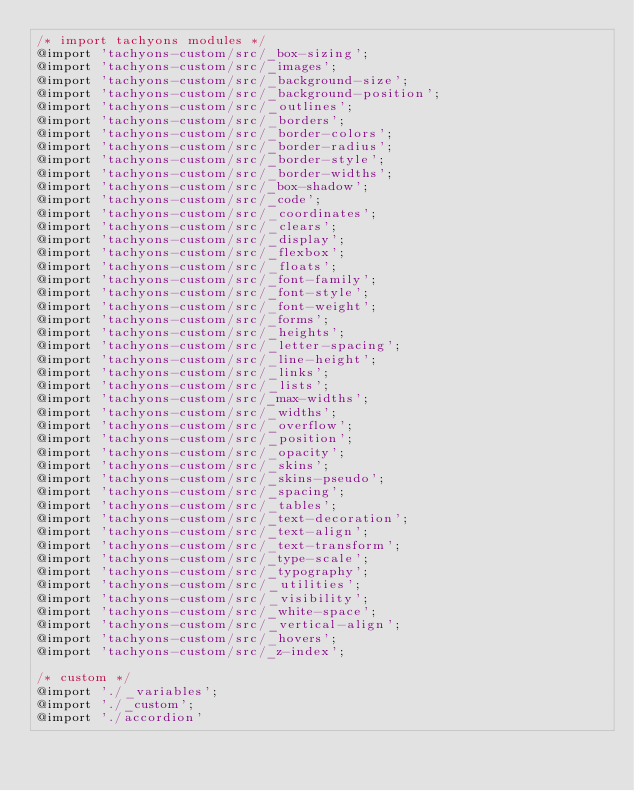<code> <loc_0><loc_0><loc_500><loc_500><_CSS_>/* import tachyons modules */
@import 'tachyons-custom/src/_box-sizing';
@import 'tachyons-custom/src/_images';
@import 'tachyons-custom/src/_background-size';
@import 'tachyons-custom/src/_background-position';
@import 'tachyons-custom/src/_outlines';
@import 'tachyons-custom/src/_borders';
@import 'tachyons-custom/src/_border-colors';
@import 'tachyons-custom/src/_border-radius';
@import 'tachyons-custom/src/_border-style';
@import 'tachyons-custom/src/_border-widths';
@import 'tachyons-custom/src/_box-shadow';
@import 'tachyons-custom/src/_code';
@import 'tachyons-custom/src/_coordinates';
@import 'tachyons-custom/src/_clears';
@import 'tachyons-custom/src/_display';
@import 'tachyons-custom/src/_flexbox';
@import 'tachyons-custom/src/_floats';
@import 'tachyons-custom/src/_font-family';
@import 'tachyons-custom/src/_font-style';
@import 'tachyons-custom/src/_font-weight';
@import 'tachyons-custom/src/_forms';
@import 'tachyons-custom/src/_heights';
@import 'tachyons-custom/src/_letter-spacing';
@import 'tachyons-custom/src/_line-height';
@import 'tachyons-custom/src/_links';
@import 'tachyons-custom/src/_lists';
@import 'tachyons-custom/src/_max-widths';
@import 'tachyons-custom/src/_widths';
@import 'tachyons-custom/src/_overflow';
@import 'tachyons-custom/src/_position';
@import 'tachyons-custom/src/_opacity';
@import 'tachyons-custom/src/_skins';
@import 'tachyons-custom/src/_skins-pseudo';
@import 'tachyons-custom/src/_spacing';
@import 'tachyons-custom/src/_tables';
@import 'tachyons-custom/src/_text-decoration';
@import 'tachyons-custom/src/_text-align';
@import 'tachyons-custom/src/_text-transform';
@import 'tachyons-custom/src/_type-scale';
@import 'tachyons-custom/src/_typography';
@import 'tachyons-custom/src/_utilities';
@import 'tachyons-custom/src/_visibility';
@import 'tachyons-custom/src/_white-space';
@import 'tachyons-custom/src/_vertical-align';
@import 'tachyons-custom/src/_hovers';
@import 'tachyons-custom/src/_z-index';

/* custom */
@import './_variables';
@import './_custom';
@import './accordion'
</code> 